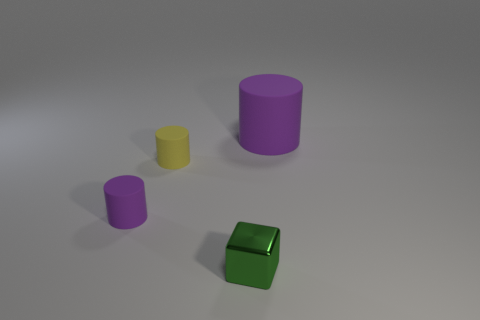What number of tiny green metallic blocks are to the left of the tiny purple cylinder? 0 